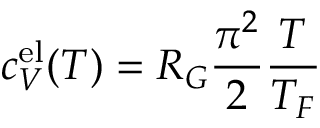Convert formula to latex. <formula><loc_0><loc_0><loc_500><loc_500>c _ { V } ^ { e l } ( T ) = R _ { G } \frac { \pi ^ { 2 } } { 2 } \frac { T } { T _ { F } }</formula> 